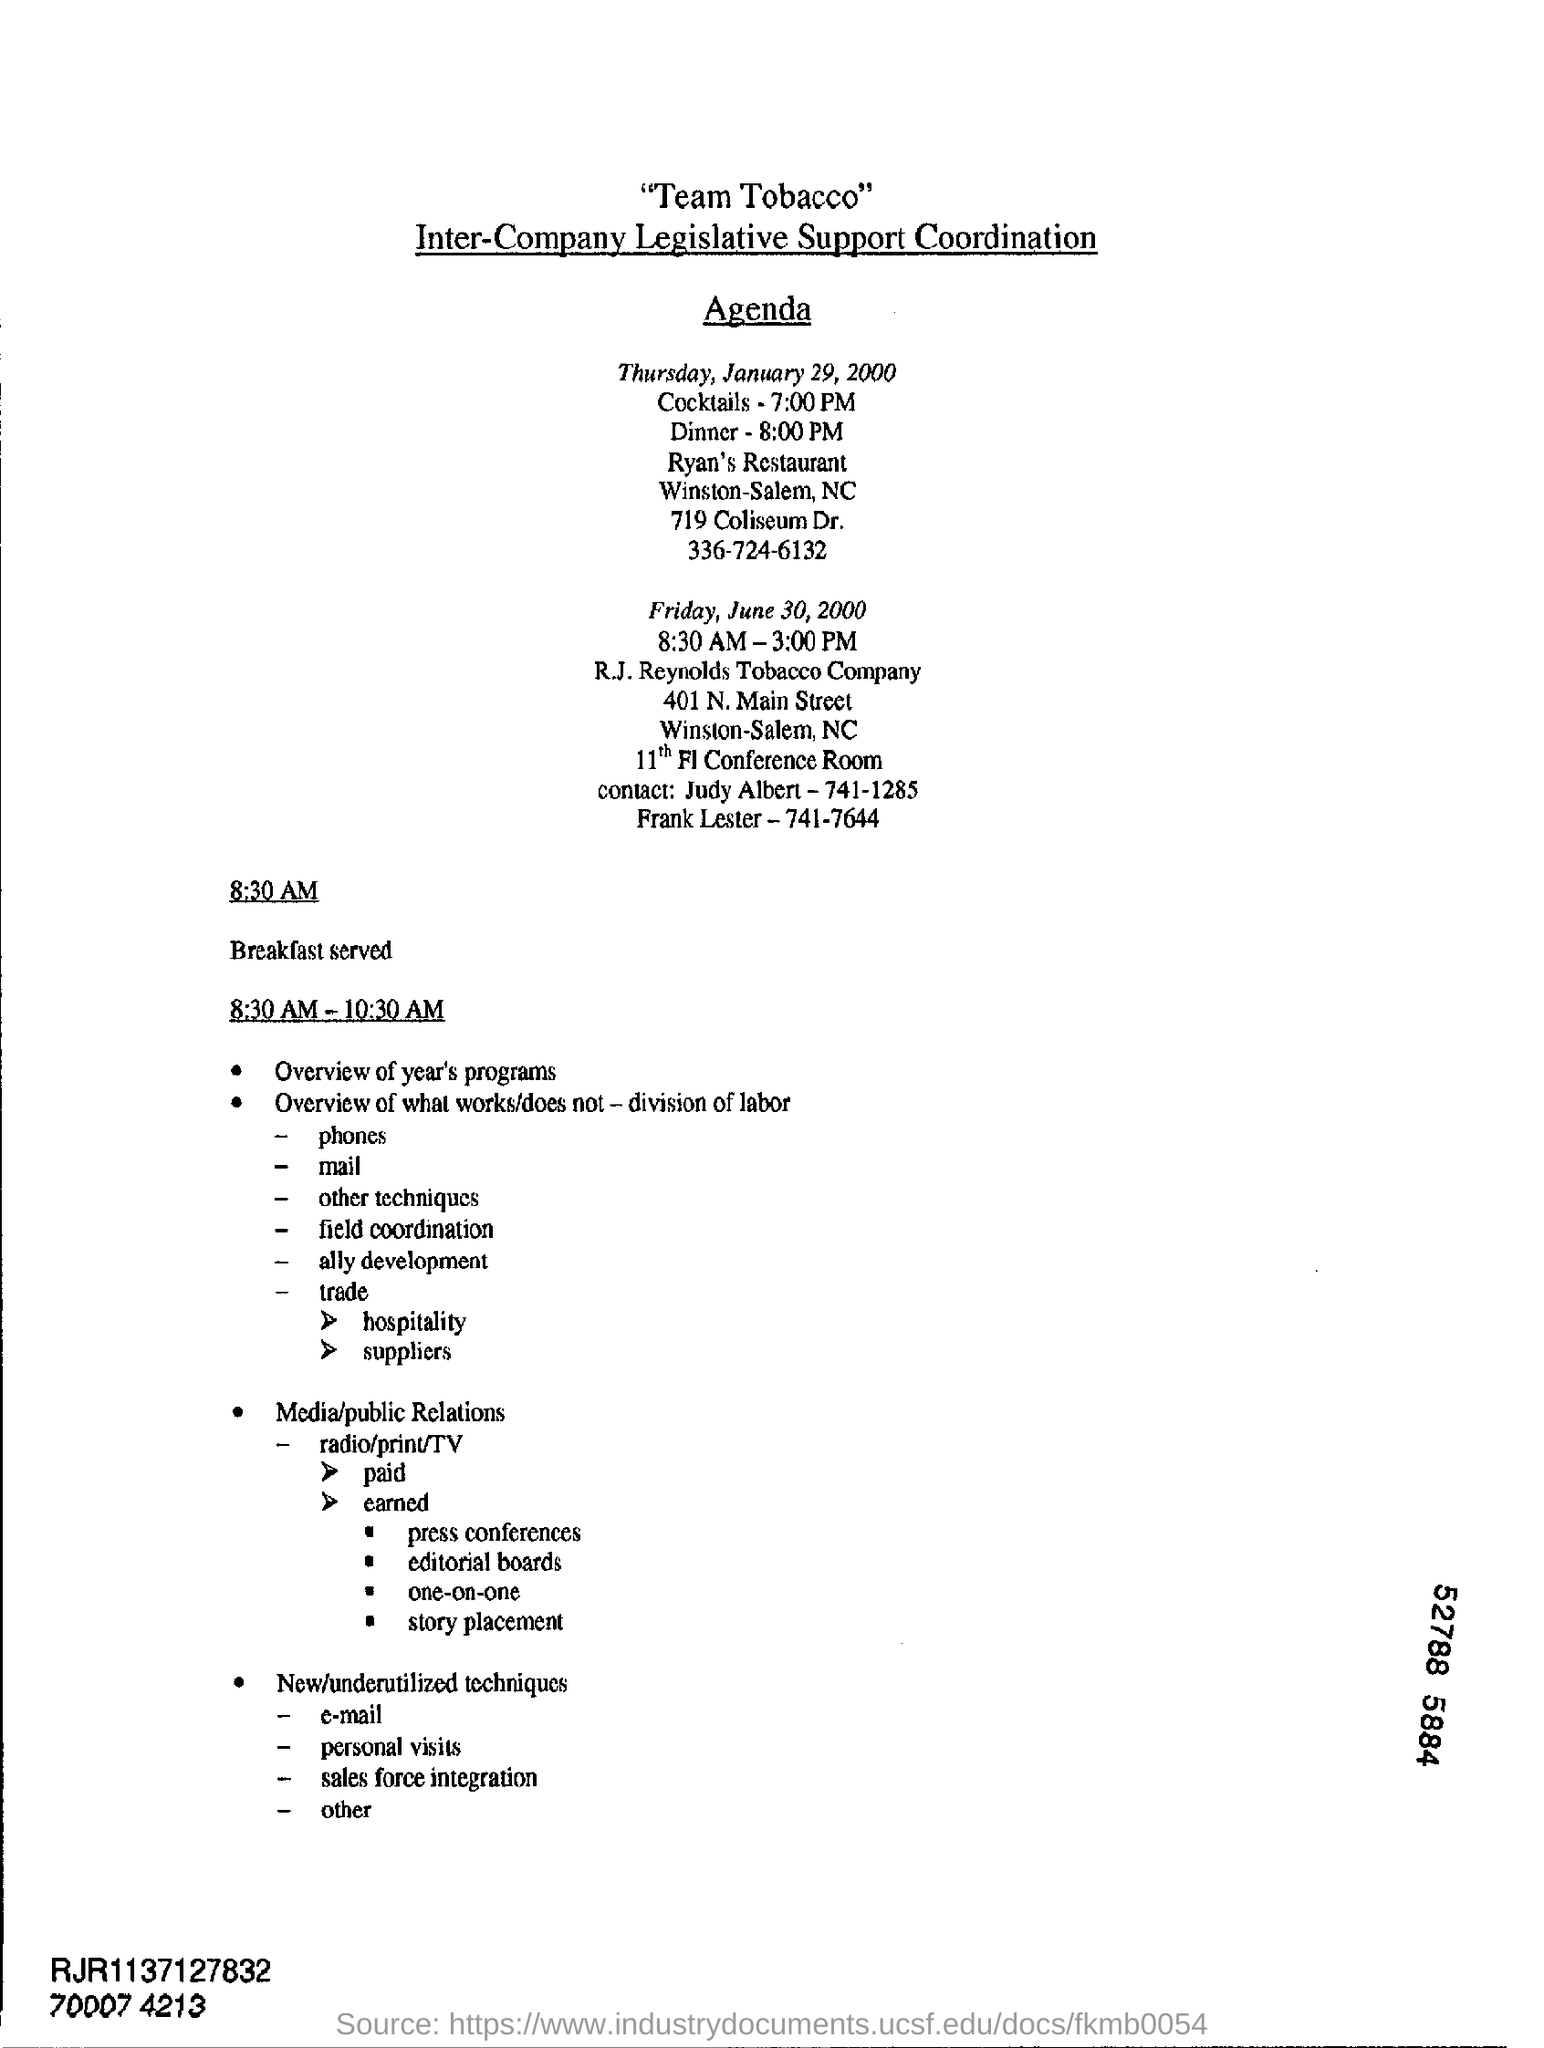What is the breakfast served time?
Provide a succinct answer. 8:30 AM. 